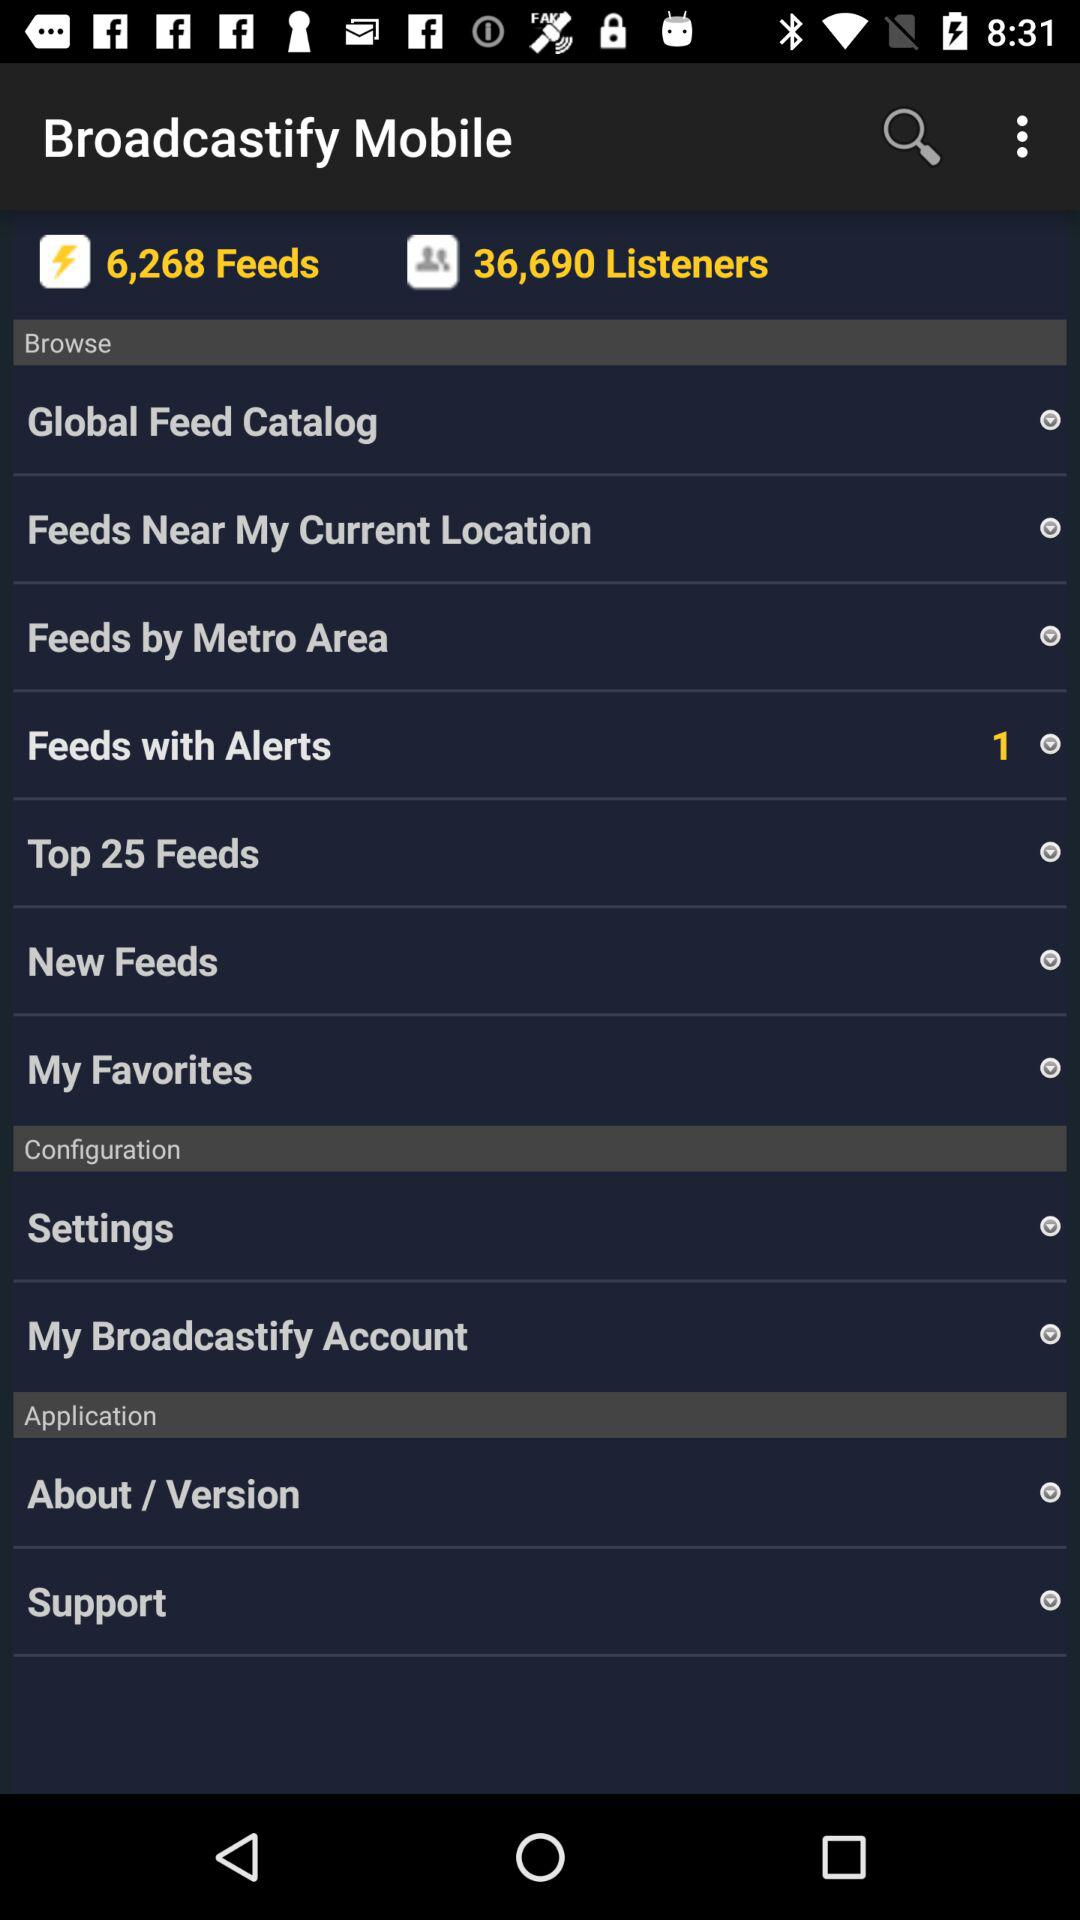What is the application name? The application name is "Broadcastify". 